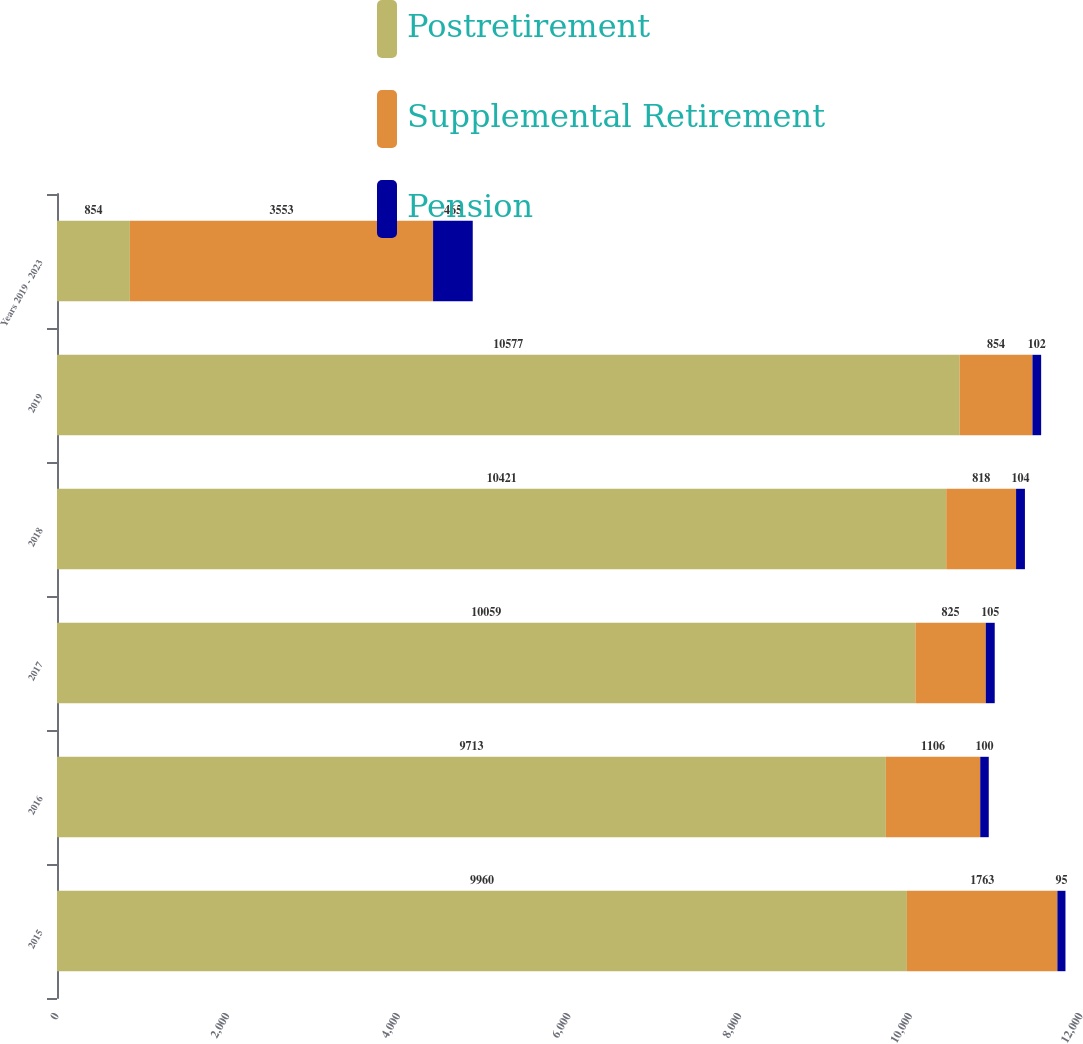Convert chart. <chart><loc_0><loc_0><loc_500><loc_500><stacked_bar_chart><ecel><fcel>2015<fcel>2016<fcel>2017<fcel>2018<fcel>2019<fcel>Years 2019 - 2023<nl><fcel>Postretirement<fcel>9960<fcel>9713<fcel>10059<fcel>10421<fcel>10577<fcel>854<nl><fcel>Supplemental Retirement<fcel>1763<fcel>1106<fcel>825<fcel>818<fcel>854<fcel>3553<nl><fcel>Pension<fcel>95<fcel>100<fcel>105<fcel>104<fcel>102<fcel>465<nl></chart> 